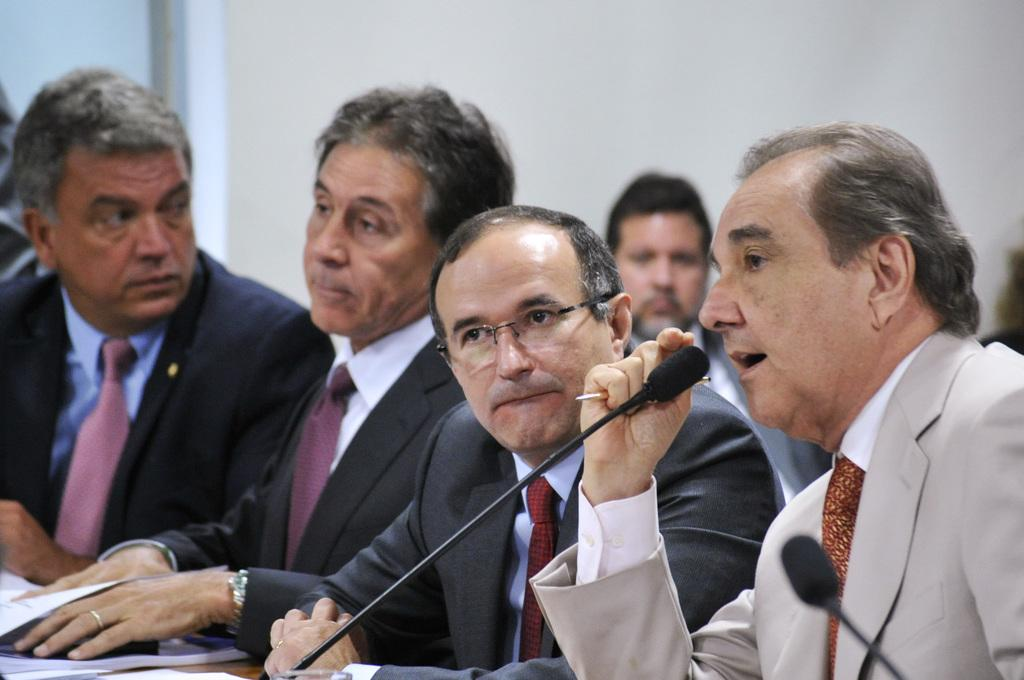What are the people in the image doing? The people in the image are sitting. Can you describe any objects in the image besides the people? Yes, there is a book on a table in the bottom left side of the image. What type of argument is taking place between the people in the image? There is no argument taking place in the image; the people are simply sitting. How does the cat's behavior change throughout the image? There is no cat present in the image, so its behavior cannot be observed. 